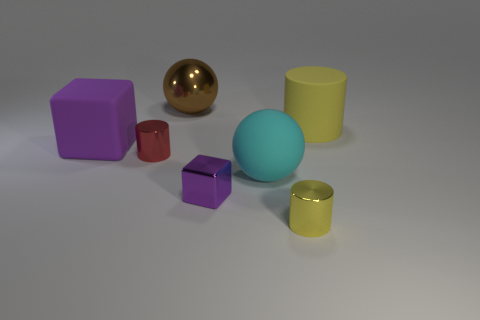What is the material of the cyan object?
Provide a succinct answer. Rubber. What number of tiny metal cylinders are both in front of the cyan matte object and behind the purple metallic thing?
Provide a succinct answer. 0. Is the size of the yellow rubber thing the same as the cyan rubber thing?
Your answer should be very brief. Yes. Is the size of the sphere to the right of the metal sphere the same as the red metal thing?
Give a very brief answer. No. What is the color of the tiny cylinder to the right of the small red metal cylinder?
Provide a short and direct response. Yellow. What number of large green matte balls are there?
Ensure brevity in your answer.  0. There is a purple object that is made of the same material as the big yellow cylinder; what is its shape?
Ensure brevity in your answer.  Cube. There is a cylinder on the left side of the cyan sphere; does it have the same color as the cylinder on the right side of the small yellow cylinder?
Your response must be concise. No. Is the number of small things that are to the left of the tiny block the same as the number of yellow metallic cylinders?
Your answer should be compact. Yes. There is a rubber cylinder; how many large spheres are in front of it?
Offer a terse response. 1. 